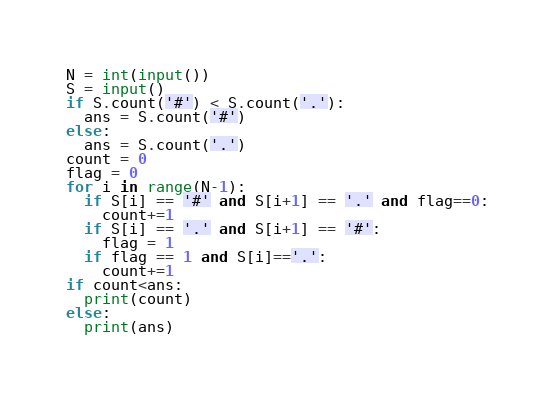<code> <loc_0><loc_0><loc_500><loc_500><_Python_>N = int(input())
S = input()
if S.count('#') < S.count('.'):
  ans = S.count('#')
else:
  ans = S.count('.')
count = 0
flag = 0
for i in range(N-1):
  if S[i] == '#' and S[i+1] == '.' and flag==0:
    count+=1
  if S[i] == '.' and S[i+1] == '#':
    flag = 1
  if flag == 1 and S[i]=='.':
    count+=1
if count<ans:
  print(count)
else:
  print(ans)
</code> 